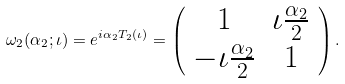Convert formula to latex. <formula><loc_0><loc_0><loc_500><loc_500>\omega _ { 2 } ( \alpha _ { 2 } ; \iota ) = e ^ { i \alpha _ { 2 } T _ { 2 } ( \iota ) } = \left ( \begin{array} { c c } 1 & \iota \frac { \alpha _ { 2 } } { 2 } \\ - \iota \frac { \alpha _ { 2 } } { 2 } & 1 \end{array} \right ) .</formula> 